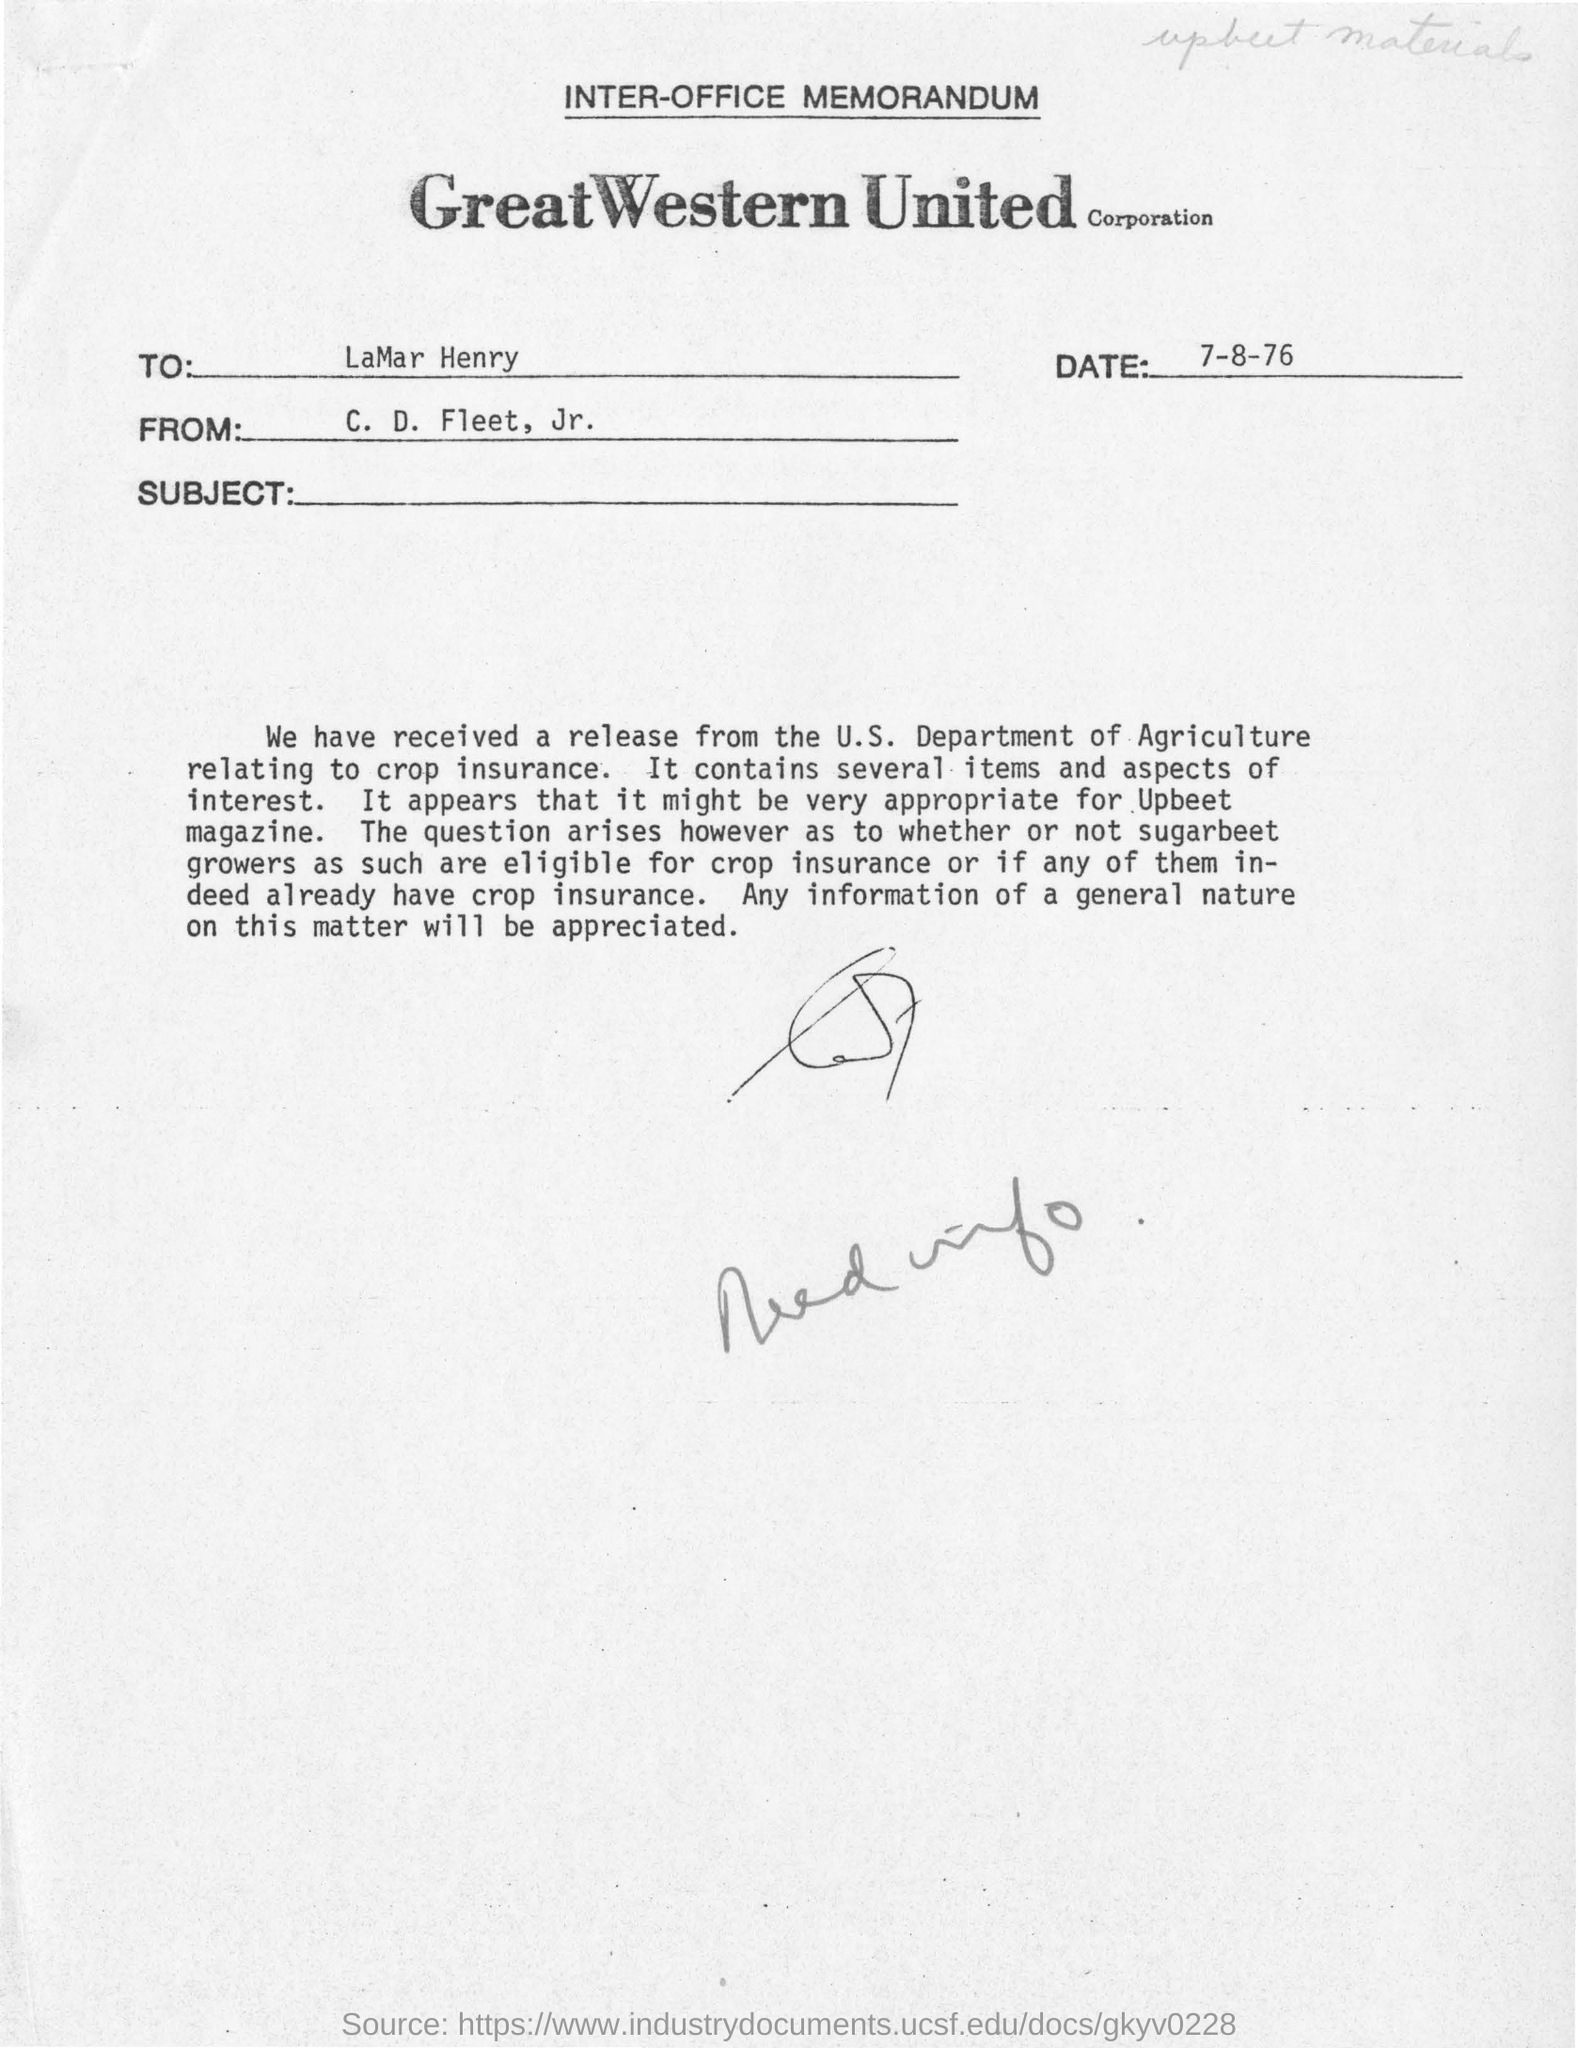Draw attention to some important aspects in this diagram. This document was created on the date of July 8, 1976. The sender of this letter is C. D. Fleet, Jr. The letter is addressed to LaMar Henry. 